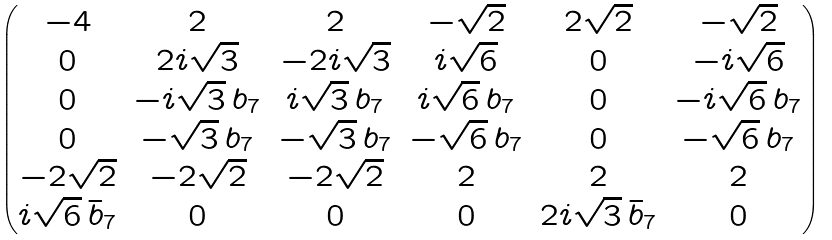Convert formula to latex. <formula><loc_0><loc_0><loc_500><loc_500>\begin{pmatrix} - 4 & 2 & 2 & - \sqrt { 2 } & 2 \sqrt { 2 } & - \sqrt { 2 } \\ 0 & 2 i \sqrt { 3 } & - 2 i \sqrt { 3 } & i \sqrt { 6 } & 0 & - i \sqrt { 6 } \\ 0 & - i \sqrt { 3 } \, b _ { 7 } & i \sqrt { 3 } \, b _ { 7 } & i \sqrt { 6 } \, b _ { 7 } & 0 & - i \sqrt { 6 } \, b _ { 7 } \\ 0 & - \sqrt { 3 } \, b _ { 7 } & - \sqrt { 3 } \, b _ { 7 } & - \sqrt { 6 } \, b _ { 7 } & 0 & - \sqrt { 6 } \, b _ { 7 } \\ - 2 \sqrt { 2 } & - 2 \sqrt { 2 } & - 2 \sqrt { 2 } & 2 & 2 & 2 \\ i \sqrt { 6 } \, \bar { b } _ { 7 } & 0 & 0 & 0 & 2 i \sqrt { 3 } \, \bar { b } _ { 7 } & 0 \end{pmatrix}</formula> 